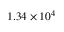<formula> <loc_0><loc_0><loc_500><loc_500>1 . 3 4 \times 1 0 ^ { 4 }</formula> 